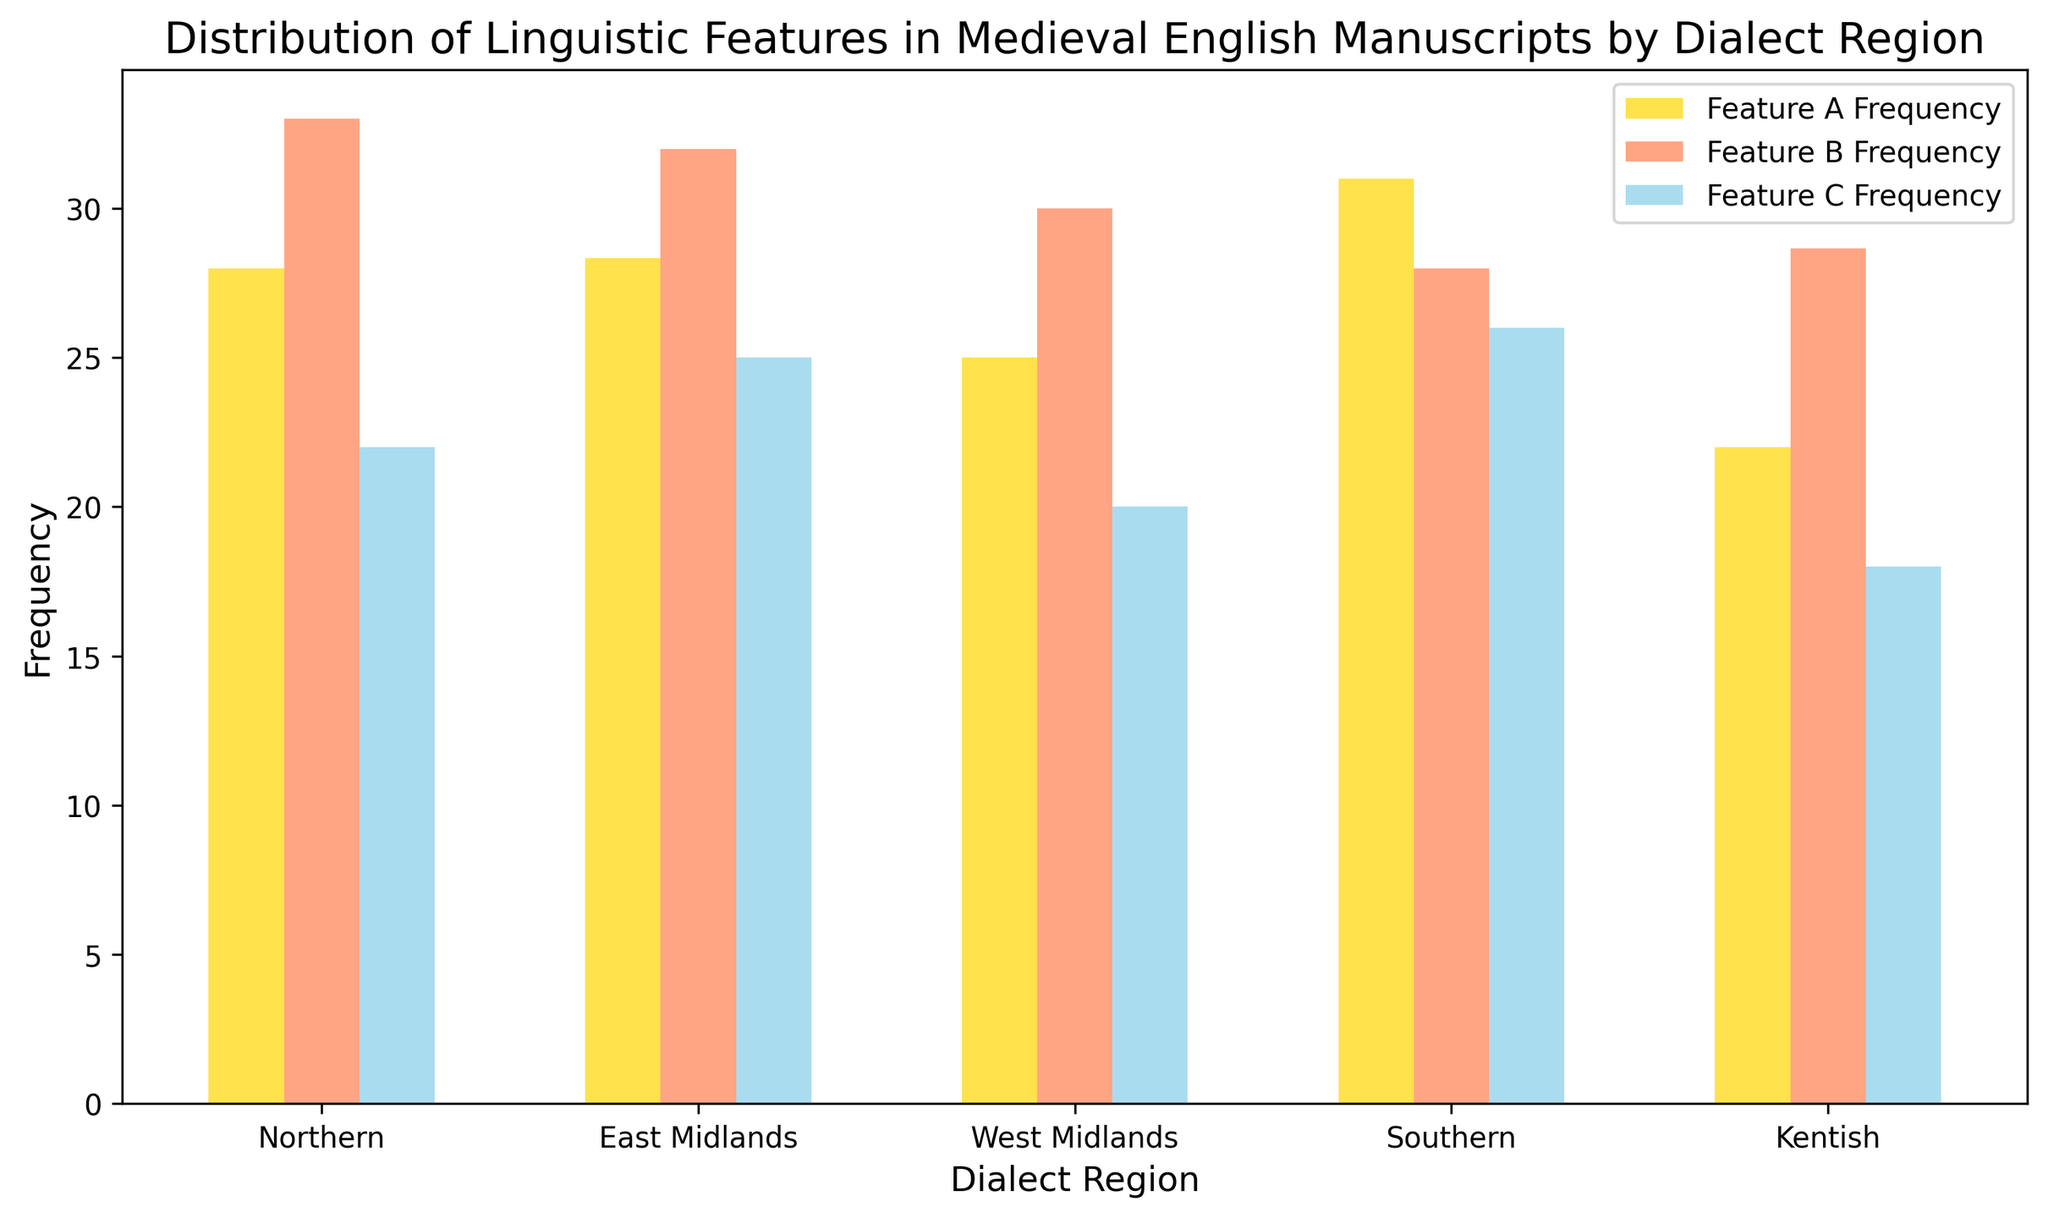What is the average frequency of Feature A in the Northern dialect region? To find the average frequency of Feature A in the Northern dialect region, sum the Feature A frequencies for the Northern region (25, 24, 26) and divide by the number of data points. (25 + 24 + 26) / 3 = 25
Answer: 25 Which dialect region shows the highest average frequency for Feature B? To determine this, compare the average frequencies of Feature B across all regions. The averages are: Northern (30), East Midlands (33), West Midlands (29), Southern (27.5), Kentish (32). The highest is 33 in the East Midlands.
Answer: East Midlands Which feature has the highest frequency in the Southern dialect region on average? Compare the average frequencies of each feature in the Southern region: Feature A (31), Feature B (28.25), Feature C (26.25). The highest is Feature A with 31.
Answer: Feature A Do any dialect regions share the same average frequency for Feature C? Check the average frequencies for Feature C in all regions to find any matching values. Northern (20), East Midlands (22), West Midlands (18), Southern (25.5), Kentish (25. No regions share the same average frequency for Feature C.
Answer: No What is the total average frequency of all features combined for the East Midlands? Sum the average frequencies of all three features for East Midlands: Feature A (28), Feature B (33), Feature C (22). (28 + 33 + 22) / 3 = 27.66
Answer: 27.66 